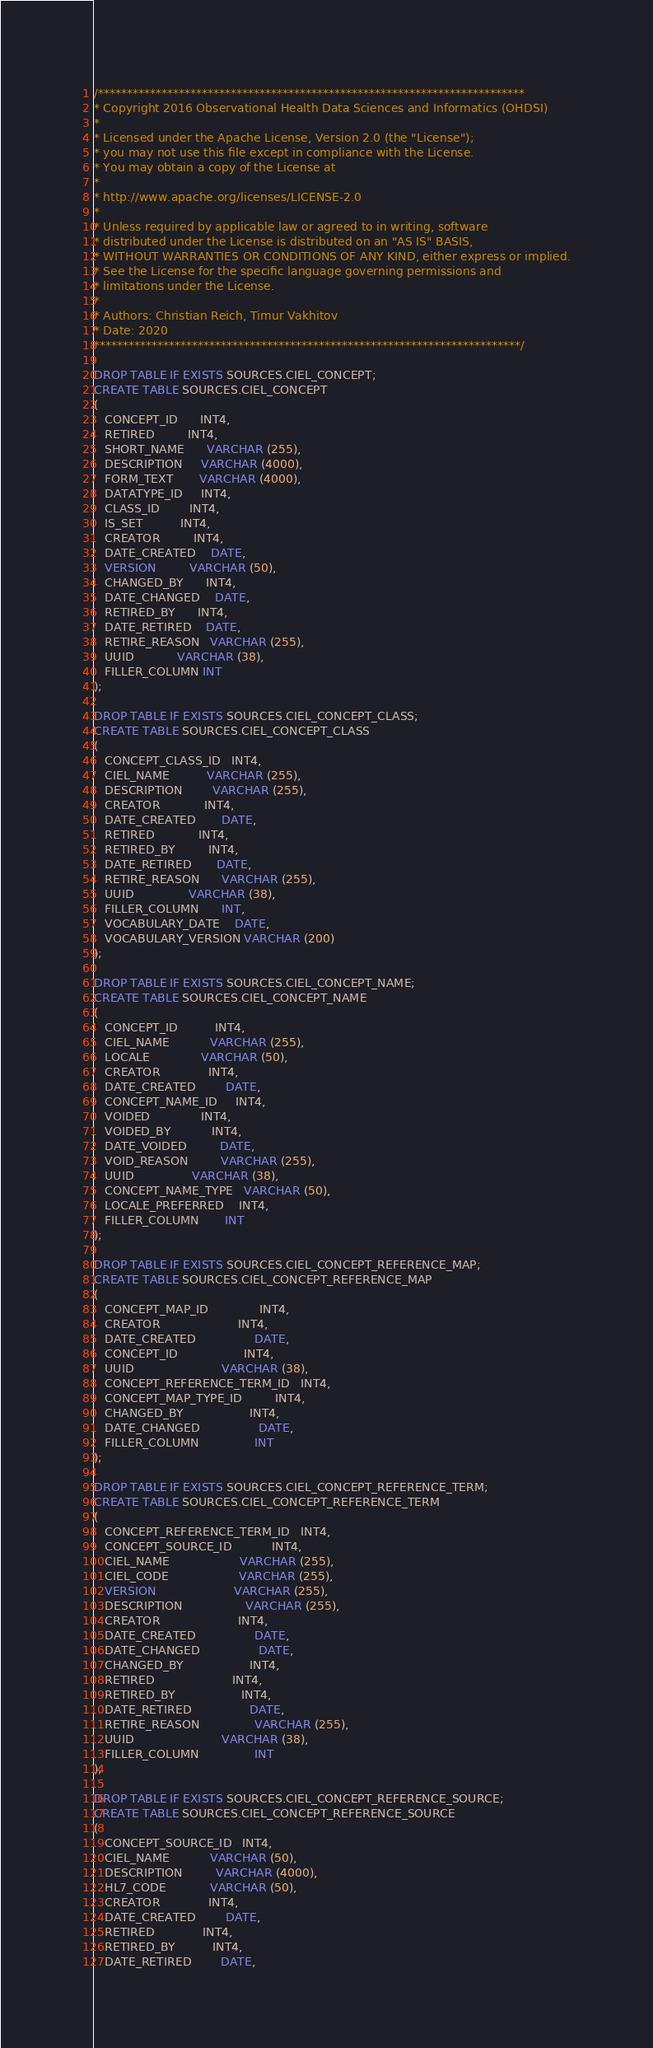<code> <loc_0><loc_0><loc_500><loc_500><_SQL_>/**************************************************************************
* Copyright 2016 Observational Health Data Sciences and Informatics (OHDSI)
*
* Licensed under the Apache License, Version 2.0 (the "License");
* you may not use this file except in compliance with the License.
* You may obtain a copy of the License at
*
* http://www.apache.org/licenses/LICENSE-2.0
*
* Unless required by applicable law or agreed to in writing, software
* distributed under the License is distributed on an "AS IS" BASIS,
* WITHOUT WARRANTIES OR CONDITIONS OF ANY KIND, either express or implied.
* See the License for the specific language governing permissions and
* limitations under the License.
* 
* Authors: Christian Reich, Timur Vakhitov
* Date: 2020
**************************************************************************/

DROP TABLE IF EXISTS SOURCES.CIEL_CONCEPT;
CREATE TABLE SOURCES.CIEL_CONCEPT
(
   CONCEPT_ID      INT4,
   RETIRED         INT4,
   SHORT_NAME      VARCHAR (255),
   DESCRIPTION     VARCHAR (4000),
   FORM_TEXT       VARCHAR (4000),
   DATATYPE_ID     INT4,
   CLASS_ID        INT4,
   IS_SET          INT4,
   CREATOR         INT4,
   DATE_CREATED    DATE,
   VERSION         VARCHAR (50),
   CHANGED_BY      INT4,
   DATE_CHANGED    DATE,
   RETIRED_BY      INT4,
   DATE_RETIRED    DATE,
   RETIRE_REASON   VARCHAR (255),
   UUID            VARCHAR (38),
   FILLER_COLUMN INT
);

DROP TABLE IF EXISTS SOURCES.CIEL_CONCEPT_CLASS;
CREATE TABLE SOURCES.CIEL_CONCEPT_CLASS
(
   CONCEPT_CLASS_ID   INT4,
   CIEL_NAME          VARCHAR (255),
   DESCRIPTION        VARCHAR (255),
   CREATOR            INT4,
   DATE_CREATED       DATE,
   RETIRED            INT4,
   RETIRED_BY         INT4,
   DATE_RETIRED       DATE,
   RETIRE_REASON      VARCHAR (255),
   UUID               VARCHAR (38),
   FILLER_COLUMN      INT,
   VOCABULARY_DATE    DATE,
   VOCABULARY_VERSION VARCHAR (200)
);

DROP TABLE IF EXISTS SOURCES.CIEL_CONCEPT_NAME;
CREATE TABLE SOURCES.CIEL_CONCEPT_NAME
(
   CONCEPT_ID          INT4,
   CIEL_NAME           VARCHAR (255),
   LOCALE              VARCHAR (50),
   CREATOR             INT4,
   DATE_CREATED        DATE,
   CONCEPT_NAME_ID     INT4,
   VOIDED              INT4,
   VOIDED_BY           INT4,
   DATE_VOIDED         DATE,
   VOID_REASON         VARCHAR (255),
   UUID                VARCHAR (38),
   CONCEPT_NAME_TYPE   VARCHAR (50),
   LOCALE_PREFERRED    INT4,
   FILLER_COLUMN       INT
);

DROP TABLE IF EXISTS SOURCES.CIEL_CONCEPT_REFERENCE_MAP;
CREATE TABLE SOURCES.CIEL_CONCEPT_REFERENCE_MAP
(
   CONCEPT_MAP_ID              INT4,
   CREATOR                     INT4,
   DATE_CREATED                DATE,
   CONCEPT_ID                  INT4,
   UUID                        VARCHAR (38),
   CONCEPT_REFERENCE_TERM_ID   INT4,
   CONCEPT_MAP_TYPE_ID         INT4,
   CHANGED_BY                  INT4,
   DATE_CHANGED                DATE,
   FILLER_COLUMN               INT
);

DROP TABLE IF EXISTS SOURCES.CIEL_CONCEPT_REFERENCE_TERM;
CREATE TABLE SOURCES.CIEL_CONCEPT_REFERENCE_TERM
(
   CONCEPT_REFERENCE_TERM_ID   INT4,
   CONCEPT_SOURCE_ID           INT4,
   CIEL_NAME                   VARCHAR (255),
   CIEL_CODE                   VARCHAR (255),
   VERSION                     VARCHAR (255),
   DESCRIPTION                 VARCHAR (255),
   CREATOR                     INT4,
   DATE_CREATED                DATE,
   DATE_CHANGED                DATE,
   CHANGED_BY                  INT4,
   RETIRED                     INT4,
   RETIRED_BY                  INT4,
   DATE_RETIRED                DATE,
   RETIRE_REASON               VARCHAR (255),
   UUID                        VARCHAR (38),
   FILLER_COLUMN               INT
);

DROP TABLE IF EXISTS SOURCES.CIEL_CONCEPT_REFERENCE_SOURCE;
CREATE TABLE SOURCES.CIEL_CONCEPT_REFERENCE_SOURCE
(
   CONCEPT_SOURCE_ID   INT4,
   CIEL_NAME           VARCHAR (50),
   DESCRIPTION         VARCHAR (4000),
   HL7_CODE            VARCHAR (50),
   CREATOR             INT4,
   DATE_CREATED        DATE,
   RETIRED             INT4,
   RETIRED_BY          INT4,
   DATE_RETIRED        DATE,</code> 